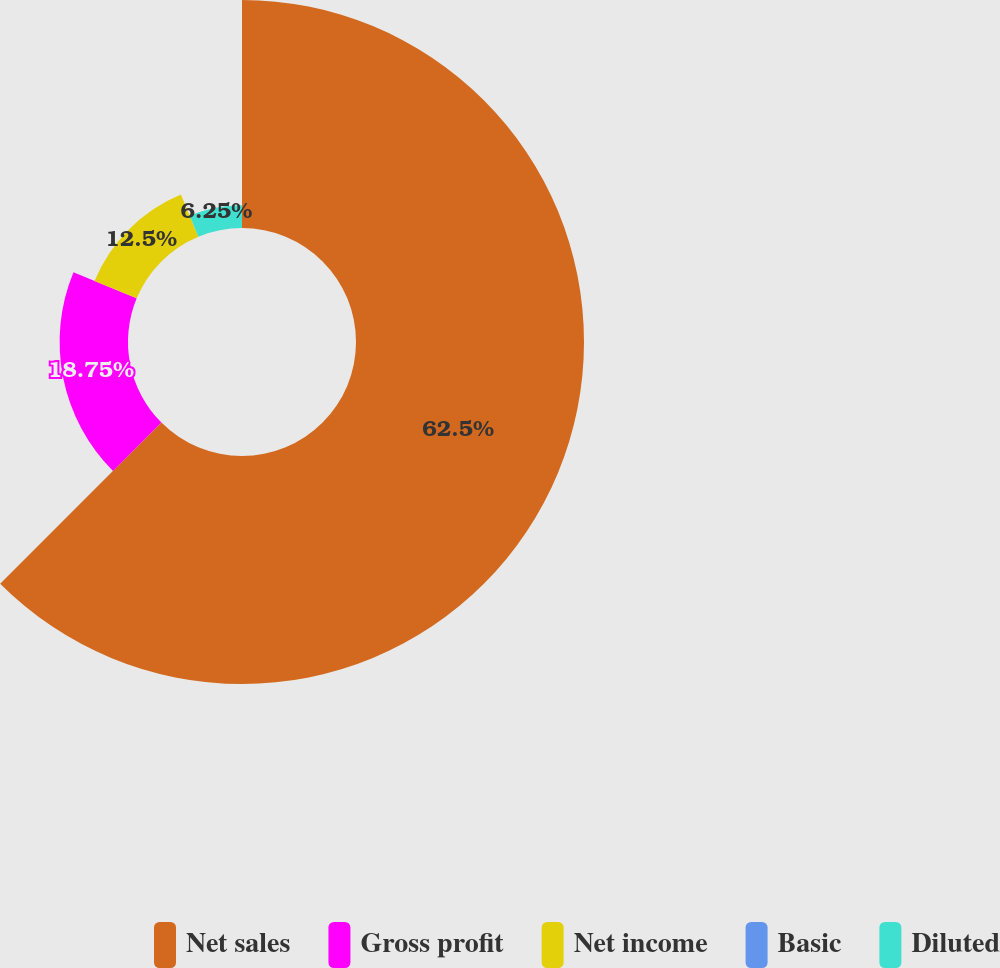Convert chart. <chart><loc_0><loc_0><loc_500><loc_500><pie_chart><fcel>Net sales<fcel>Gross profit<fcel>Net income<fcel>Basic<fcel>Diluted<nl><fcel>62.5%<fcel>18.75%<fcel>12.5%<fcel>0.0%<fcel>6.25%<nl></chart> 